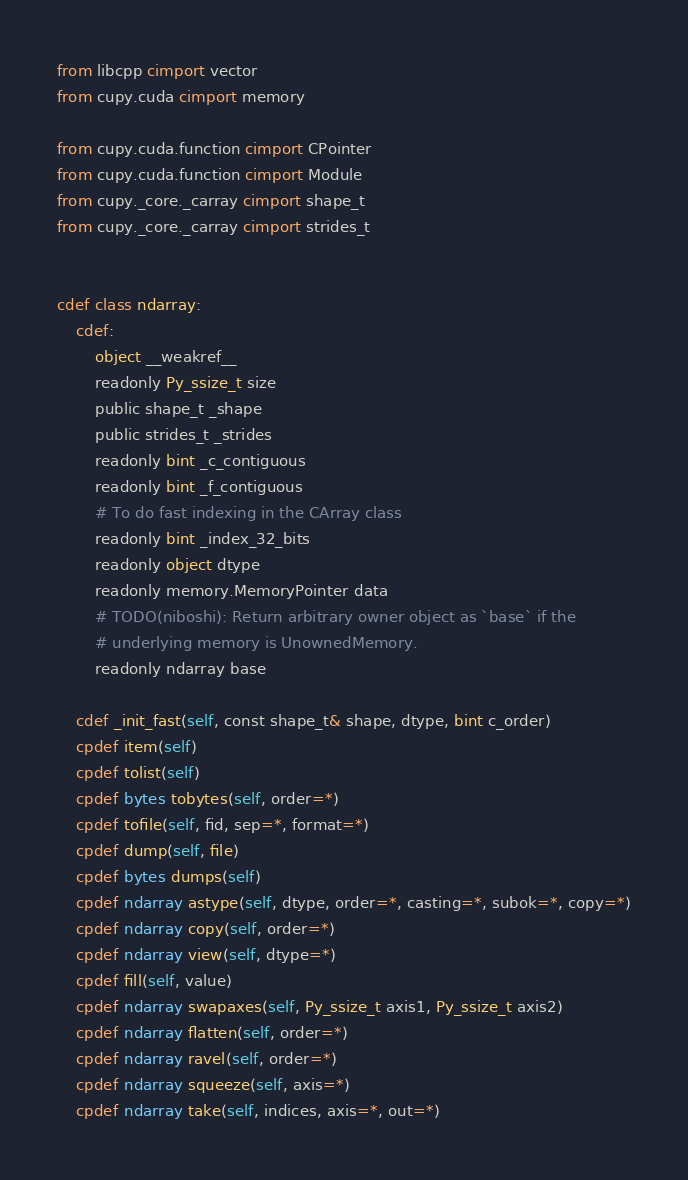Convert code to text. <code><loc_0><loc_0><loc_500><loc_500><_Cython_>from libcpp cimport vector
from cupy.cuda cimport memory

from cupy.cuda.function cimport CPointer
from cupy.cuda.function cimport Module
from cupy._core._carray cimport shape_t
from cupy._core._carray cimport strides_t


cdef class ndarray:
    cdef:
        object __weakref__
        readonly Py_ssize_t size
        public shape_t _shape
        public strides_t _strides
        readonly bint _c_contiguous
        readonly bint _f_contiguous
        # To do fast indexing in the CArray class
        readonly bint _index_32_bits
        readonly object dtype
        readonly memory.MemoryPointer data
        # TODO(niboshi): Return arbitrary owner object as `base` if the
        # underlying memory is UnownedMemory.
        readonly ndarray base

    cdef _init_fast(self, const shape_t& shape, dtype, bint c_order)
    cpdef item(self)
    cpdef tolist(self)
    cpdef bytes tobytes(self, order=*)
    cpdef tofile(self, fid, sep=*, format=*)
    cpdef dump(self, file)
    cpdef bytes dumps(self)
    cpdef ndarray astype(self, dtype, order=*, casting=*, subok=*, copy=*)
    cpdef ndarray copy(self, order=*)
    cpdef ndarray view(self, dtype=*)
    cpdef fill(self, value)
    cpdef ndarray swapaxes(self, Py_ssize_t axis1, Py_ssize_t axis2)
    cpdef ndarray flatten(self, order=*)
    cpdef ndarray ravel(self, order=*)
    cpdef ndarray squeeze(self, axis=*)
    cpdef ndarray take(self, indices, axis=*, out=*)</code> 